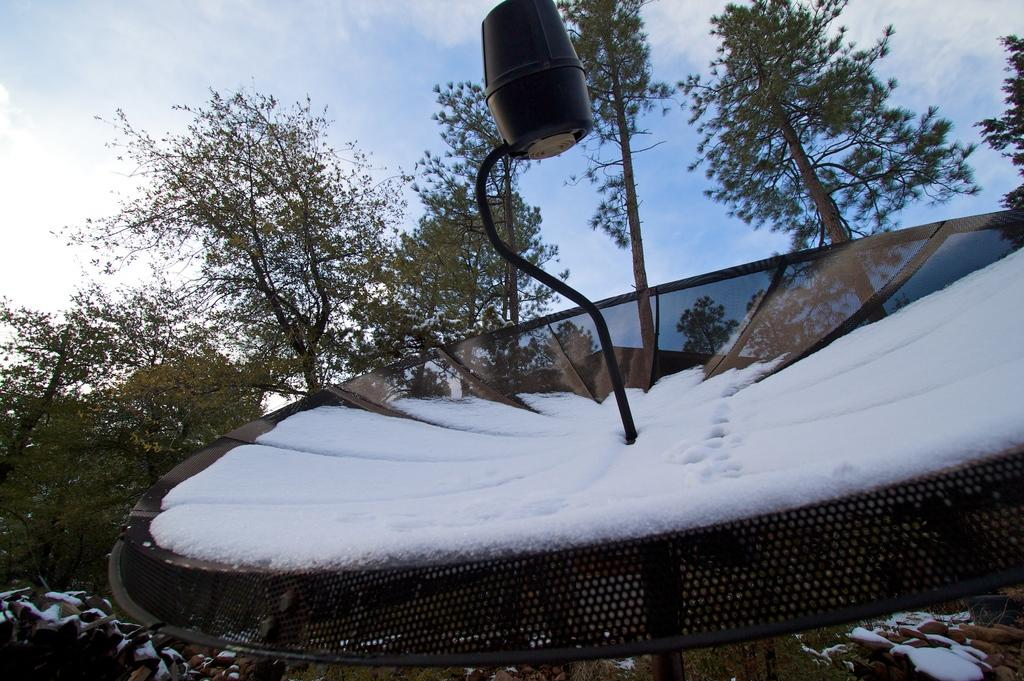What is the main object in the picture? There is a dish antenna in the picture. What is covering the dish antenna? There is snow on the dish antenna. What can be seen in the background of the picture? There are trees in the background of the picture. How would you describe the sky in the picture? The sky is clear in the picture. Can you see the crow's afterthought in the image? There is no crow or afterthought present in the image. How does the dish antenna take a breath in the image? The dish antenna is an inanimate object and does not breathe. 